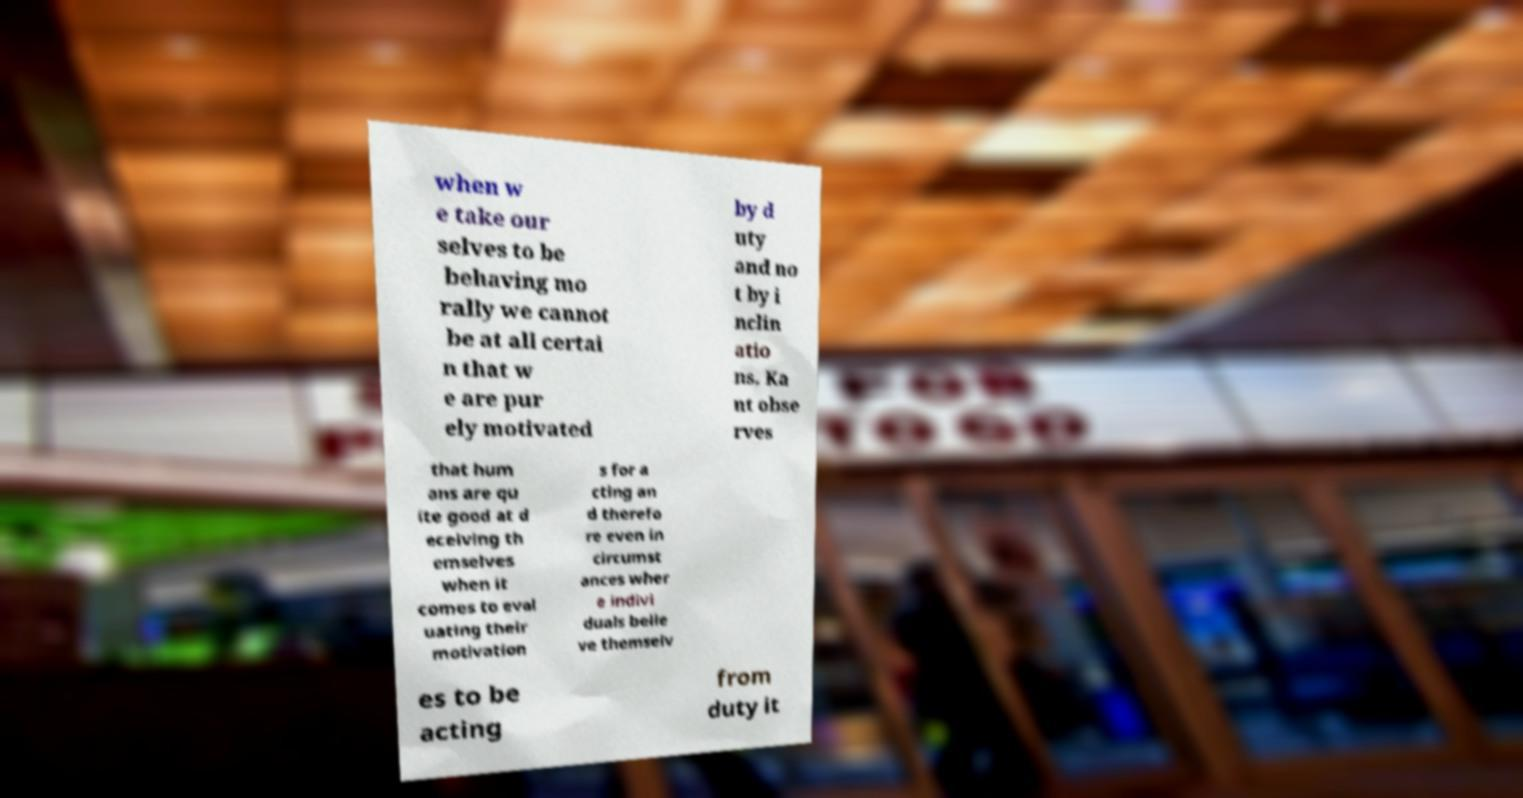What messages or text are displayed in this image? I need them in a readable, typed format. when w e take our selves to be behaving mo rally we cannot be at all certai n that w e are pur ely motivated by d uty and no t by i nclin atio ns. Ka nt obse rves that hum ans are qu ite good at d eceiving th emselves when it comes to eval uating their motivation s for a cting an d therefo re even in circumst ances wher e indivi duals belie ve themselv es to be acting from duty it 